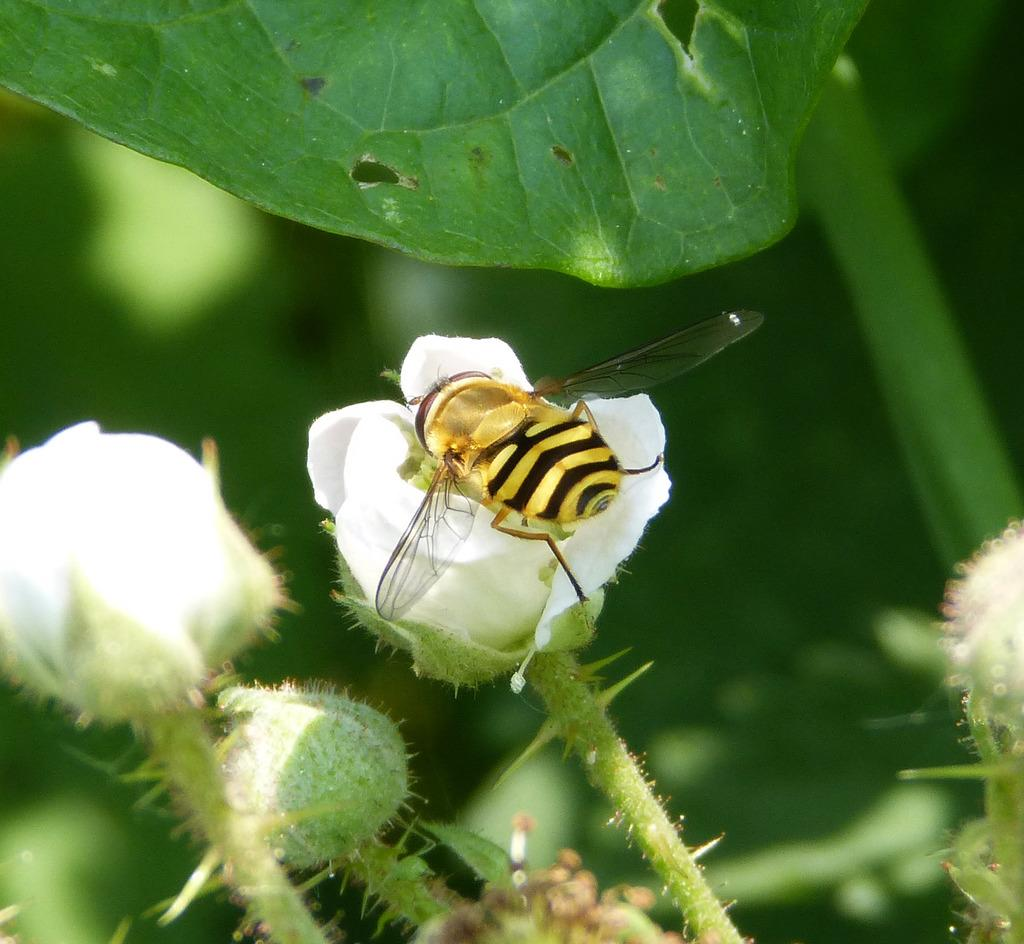What type of flowers can be seen in the image? There are white color flowers in the image. Is there any wildlife interacting with the flowers? Yes, there is a bee on a flower in the image. What else can be seen in the image besides flowers and the bee? Leaves are visible in the image. How would you describe the background of the image? The background of the image is blurred. What grade does the bee receive for its performance in the image? There is no grading system or performance evaluation for the bee in the image. 